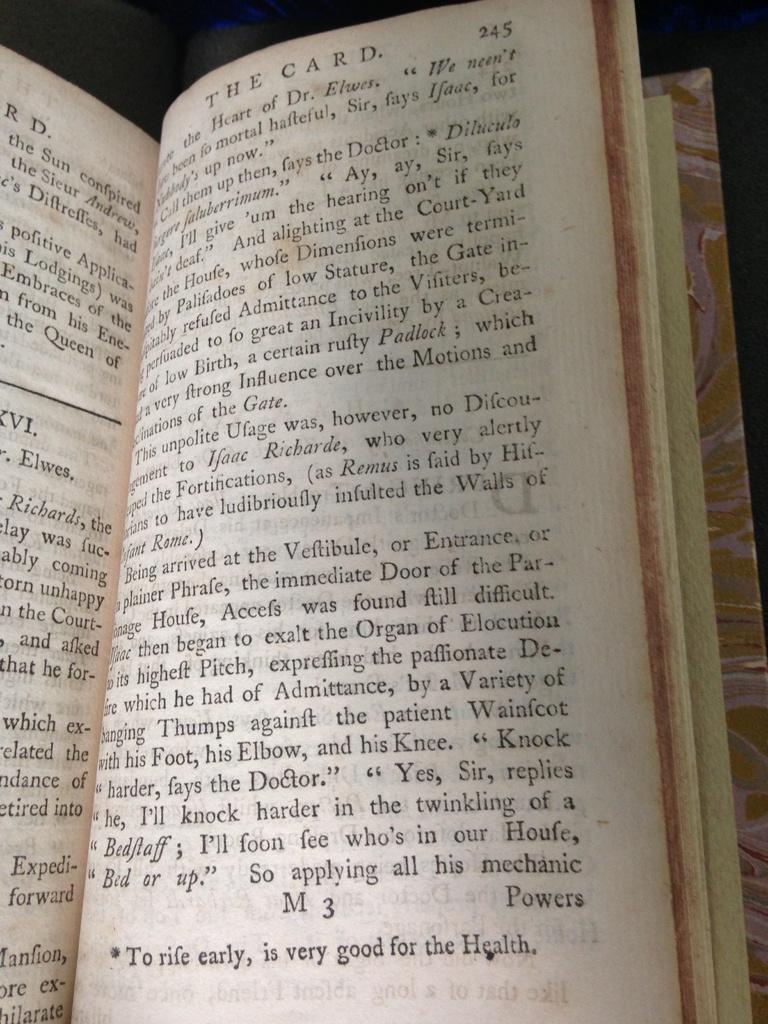What is the page number of the book?
Your answer should be very brief. 245. What is the title of this page?
Offer a very short reply. The card. 